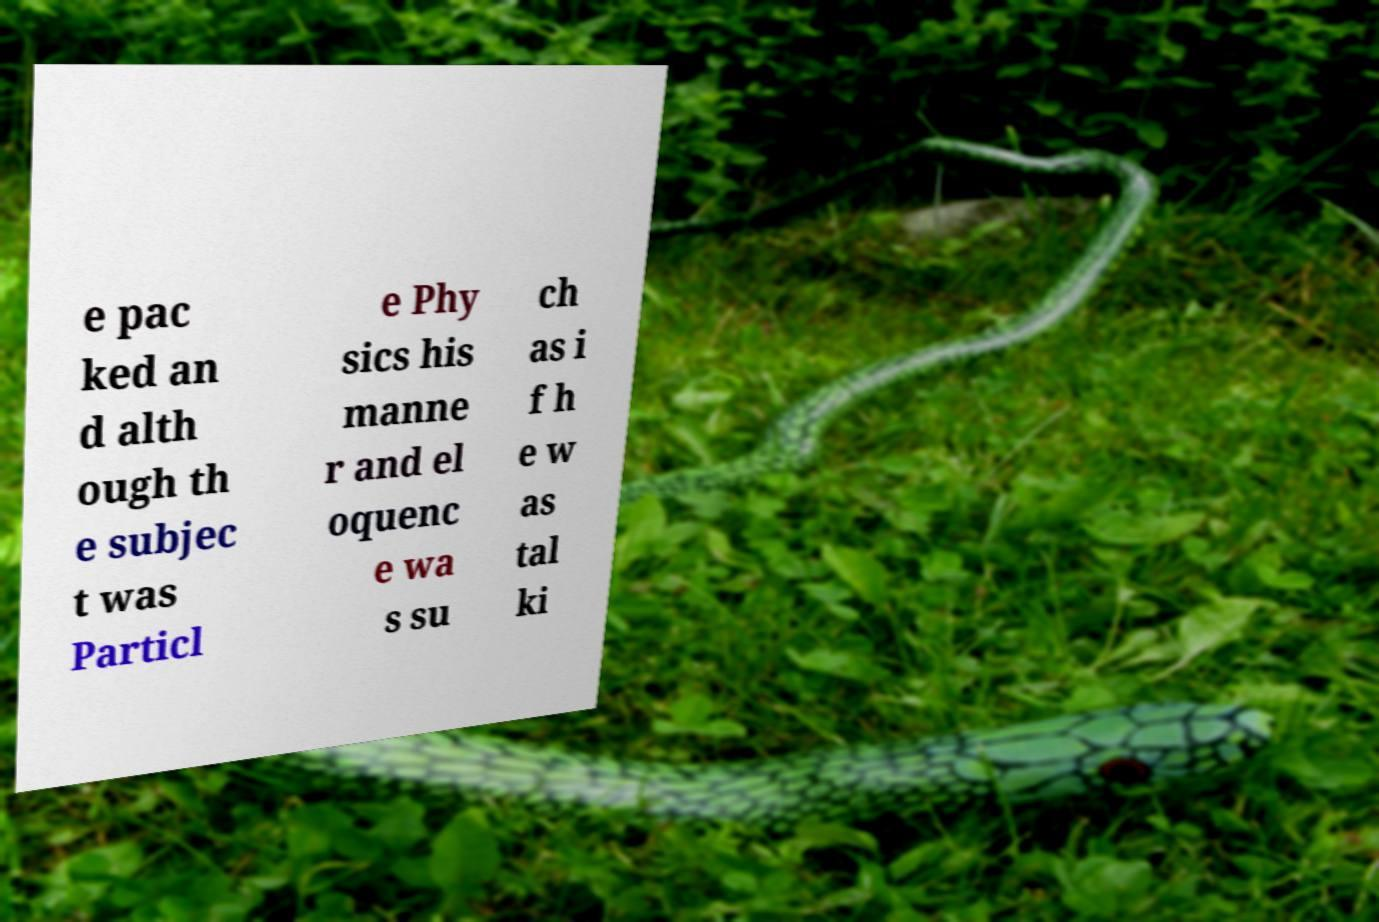For documentation purposes, I need the text within this image transcribed. Could you provide that? e pac ked an d alth ough th e subjec t was Particl e Phy sics his manne r and el oquenc e wa s su ch as i f h e w as tal ki 